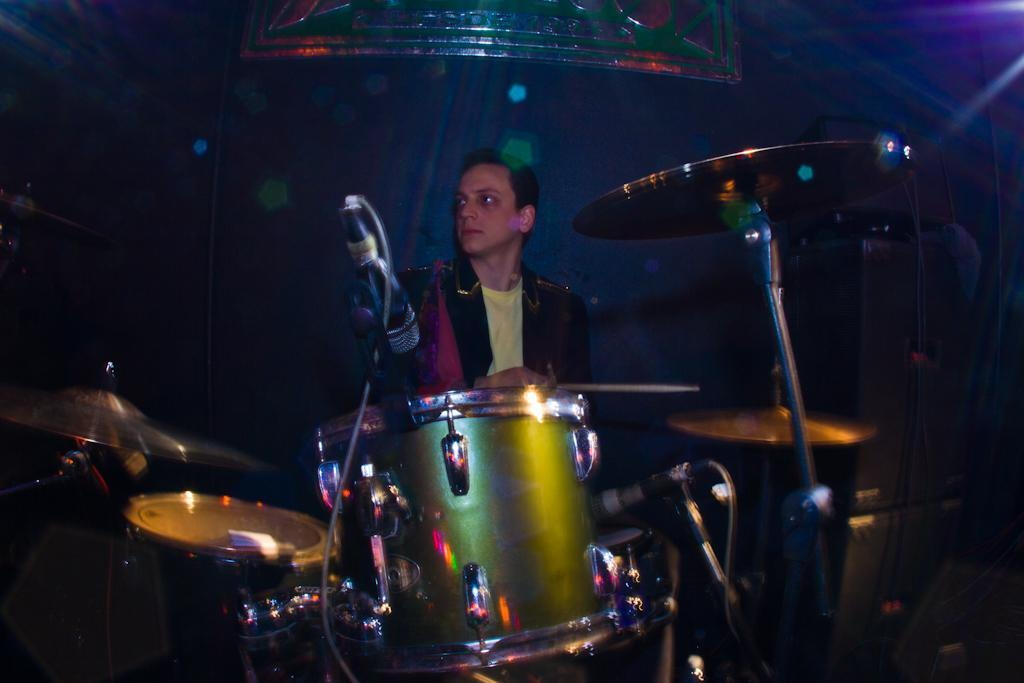Who or what is the main subject in the image? There is a person in the image. What is the person doing or standing near in the image? The person is in front of a drum set. What object is the person holding in the image? The person is holding a stick. What can be seen in the background of the image? There are lights visible in the background of the image. What type of calculator is being used by the person in the image? There is no calculator present in the image; the person is in front of a drum set and holding a stick. How much honey is visible in the image? There is no honey present in the image. 